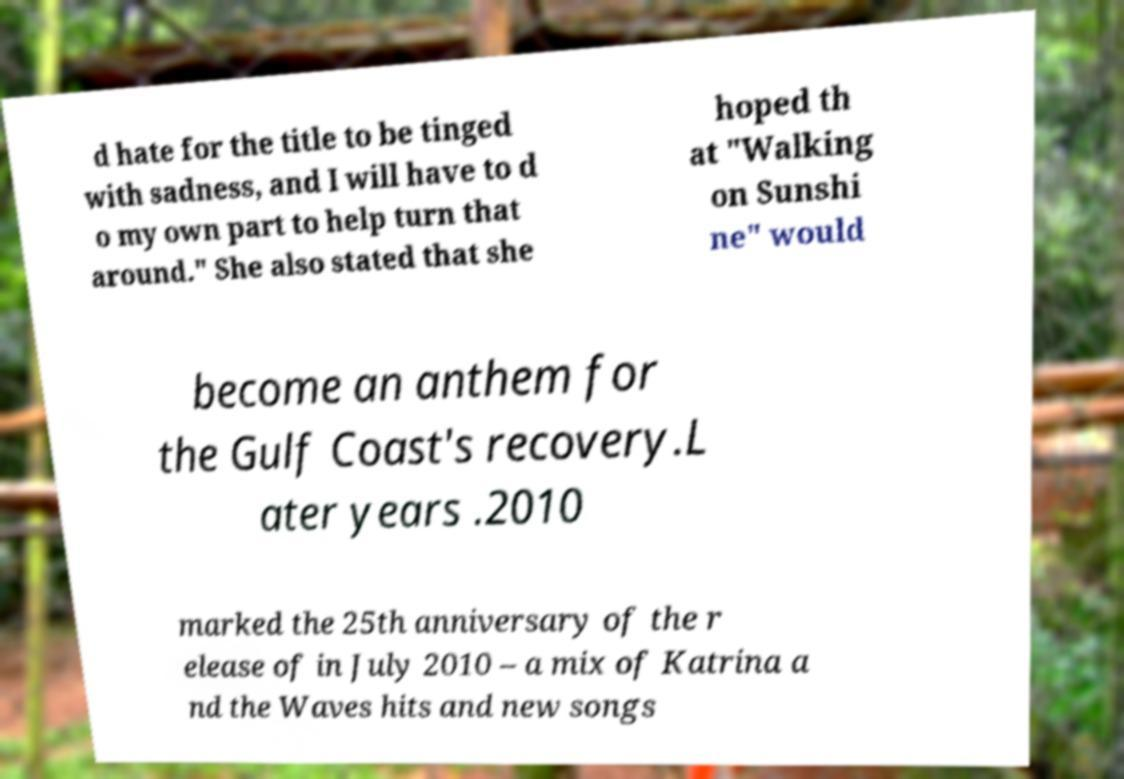Please read and relay the text visible in this image. What does it say? d hate for the title to be tinged with sadness, and I will have to d o my own part to help turn that around." She also stated that she hoped th at "Walking on Sunshi ne" would become an anthem for the Gulf Coast's recovery.L ater years .2010 marked the 25th anniversary of the r elease of in July 2010 – a mix of Katrina a nd the Waves hits and new songs 